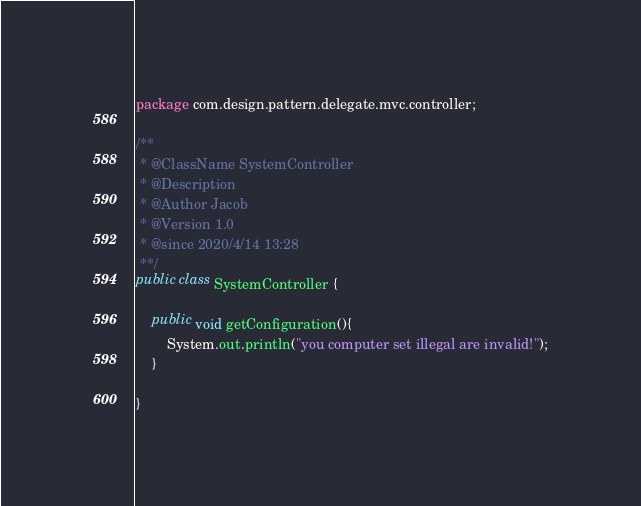Convert code to text. <code><loc_0><loc_0><loc_500><loc_500><_Java_>package com.design.pattern.delegate.mvc.controller;

/**
 * @ClassName SystemController
 * @Description
 * @Author Jacob
 * @Version 1.0
 * @since 2020/4/14 13:28
 **/
public class SystemController {

	public void getConfiguration(){
		System.out.println("you computer set illegal are invalid!");
	}

}
</code> 